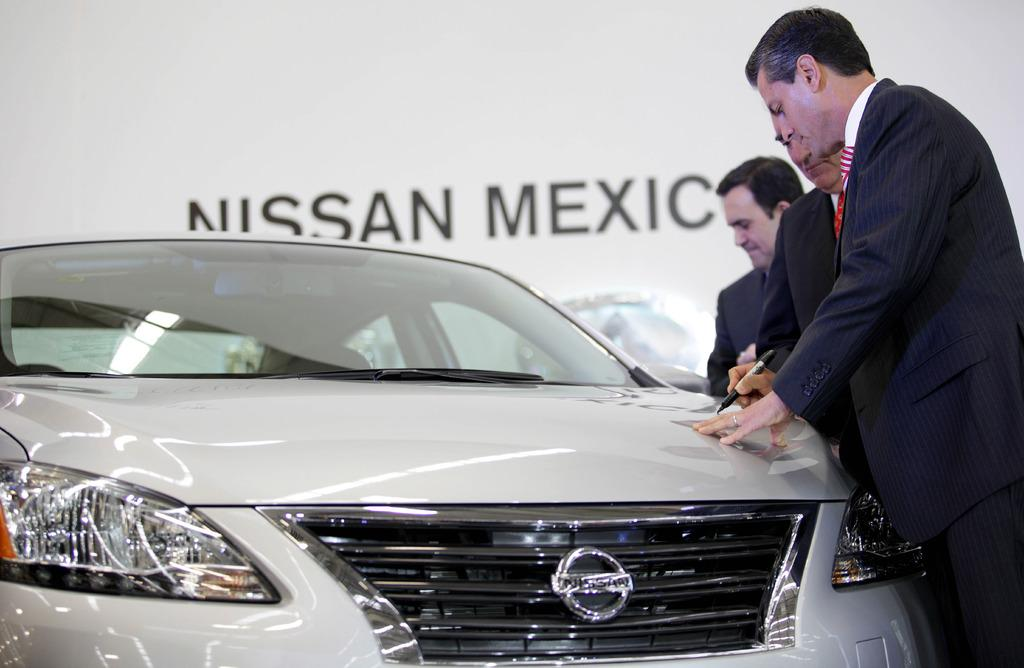How many people are visible in the foreground of the image? There are two men standing in the foreground of the image. Can you describe the person in the background of the image? There is another person in the background of the image, but their appearance cannot be clearly discerned. What is located on the left side of the image? There is a car on the left side of the image. What is the color of the banner in the background of the image? The banner in the background of the image is white. What type of stove is visible in the image? There is no stove present in the image. How many boots can be seen on the person in the background? There is no person's footwear visible in the image, as the person in the background cannot be clearly discerned. 